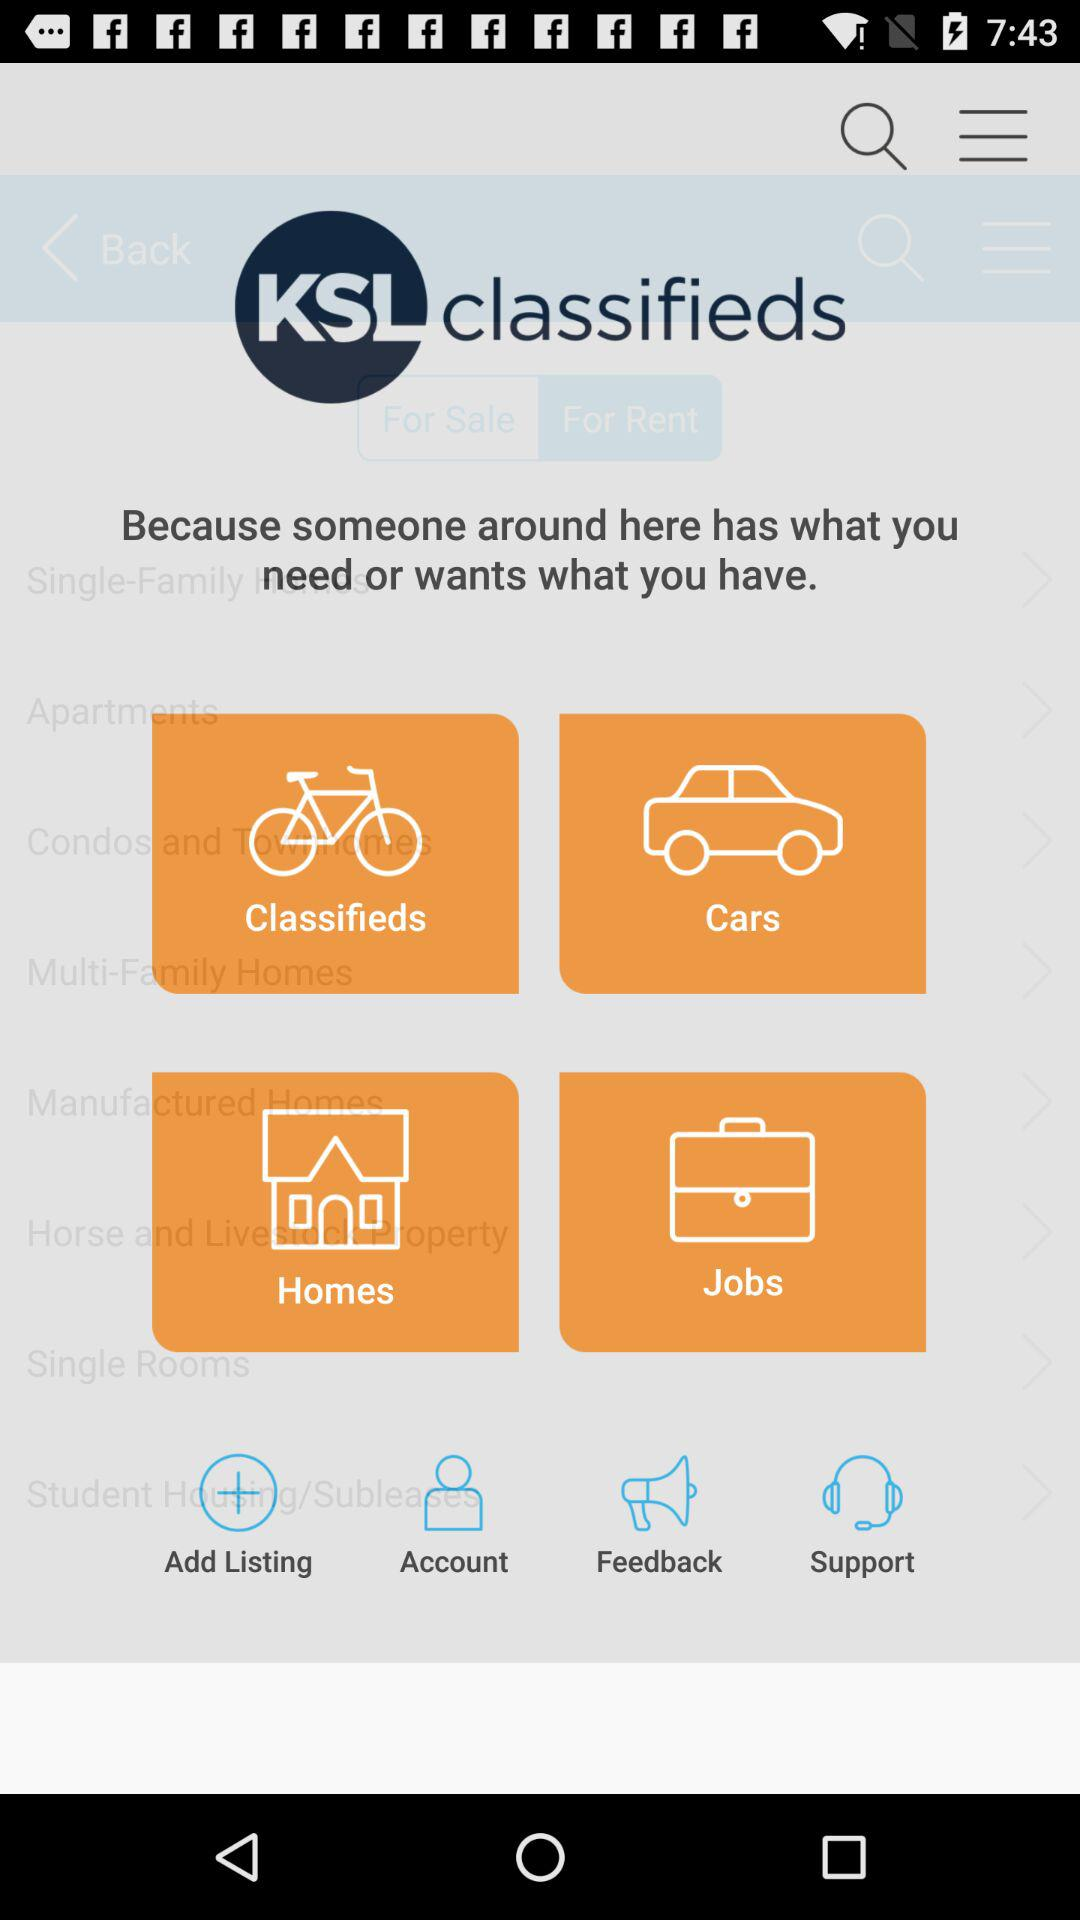What is the name of the application? The application name is "KSL classifieds". 